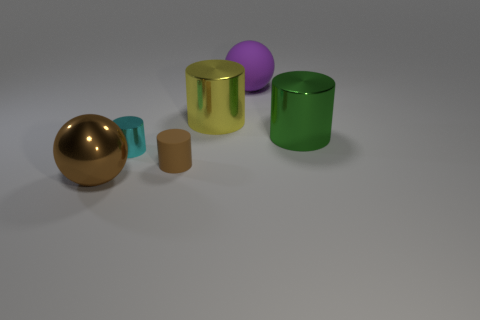Subtract all cyan cylinders. How many cylinders are left? 3 Subtract 1 cylinders. How many cylinders are left? 3 Subtract all cyan cylinders. How many cylinders are left? 3 Add 3 big red things. How many objects exist? 9 Subtract all cylinders. How many objects are left? 2 Subtract all blue cylinders. Subtract all red balls. How many cylinders are left? 4 Subtract all purple matte balls. Subtract all tiny things. How many objects are left? 3 Add 2 big metal balls. How many big metal balls are left? 3 Add 4 green objects. How many green objects exist? 5 Subtract 0 green spheres. How many objects are left? 6 